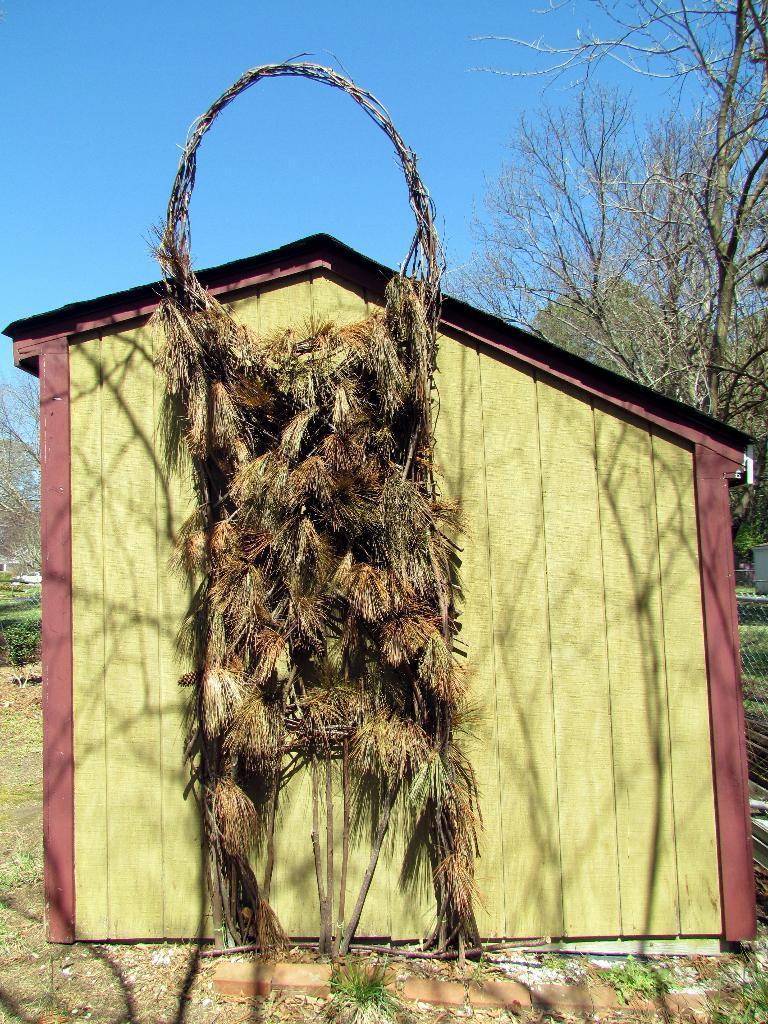How would you summarize this image in a sentence or two? In this image there is a wooden house and on the wooden house there is a structure with dry grass is hanging, behind the house there are trees and the sky. 